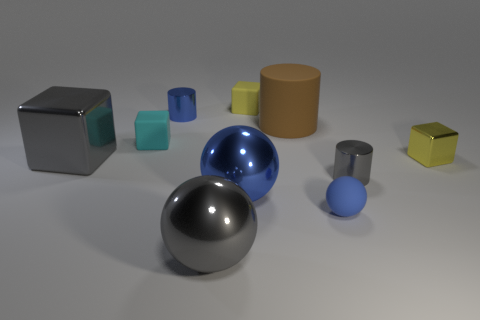Subtract all big balls. How many balls are left? 1 Subtract all blocks. How many objects are left? 6 Subtract 1 spheres. How many spheres are left? 2 Subtract all brown cylinders. How many cylinders are left? 2 Subtract all blue cubes. How many green cylinders are left? 0 Subtract 0 red cylinders. How many objects are left? 10 Subtract all cyan blocks. Subtract all red cylinders. How many blocks are left? 3 Subtract all big metallic balls. Subtract all big brown things. How many objects are left? 7 Add 4 large blocks. How many large blocks are left? 5 Add 5 cyan spheres. How many cyan spheres exist? 5 